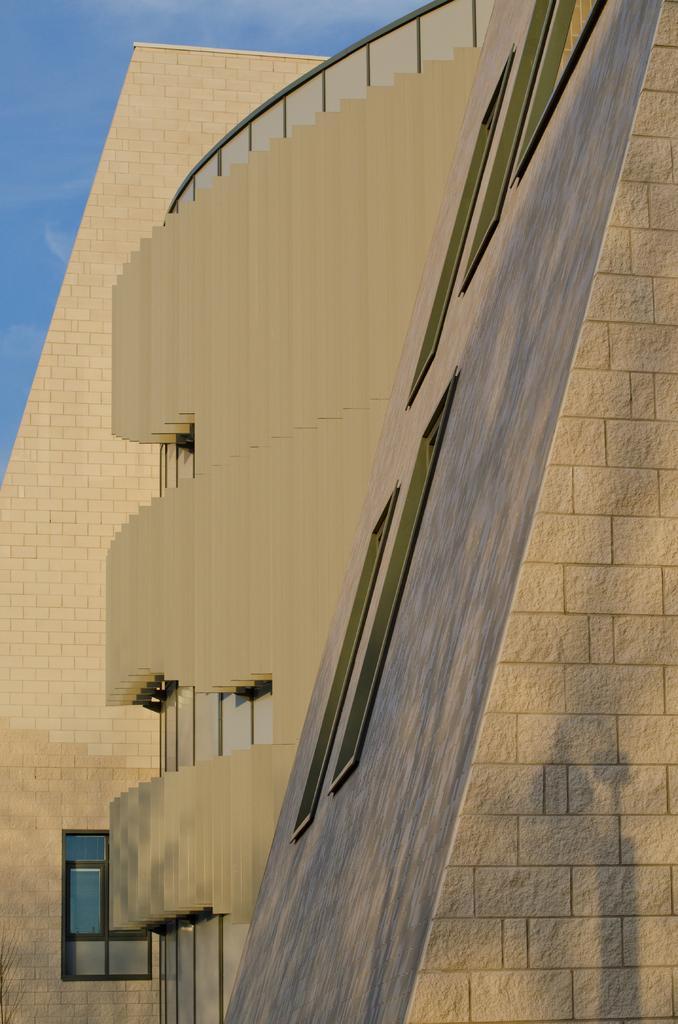Please provide a concise description of this image. In this image, there are a few buildings. We can also see the sky. 